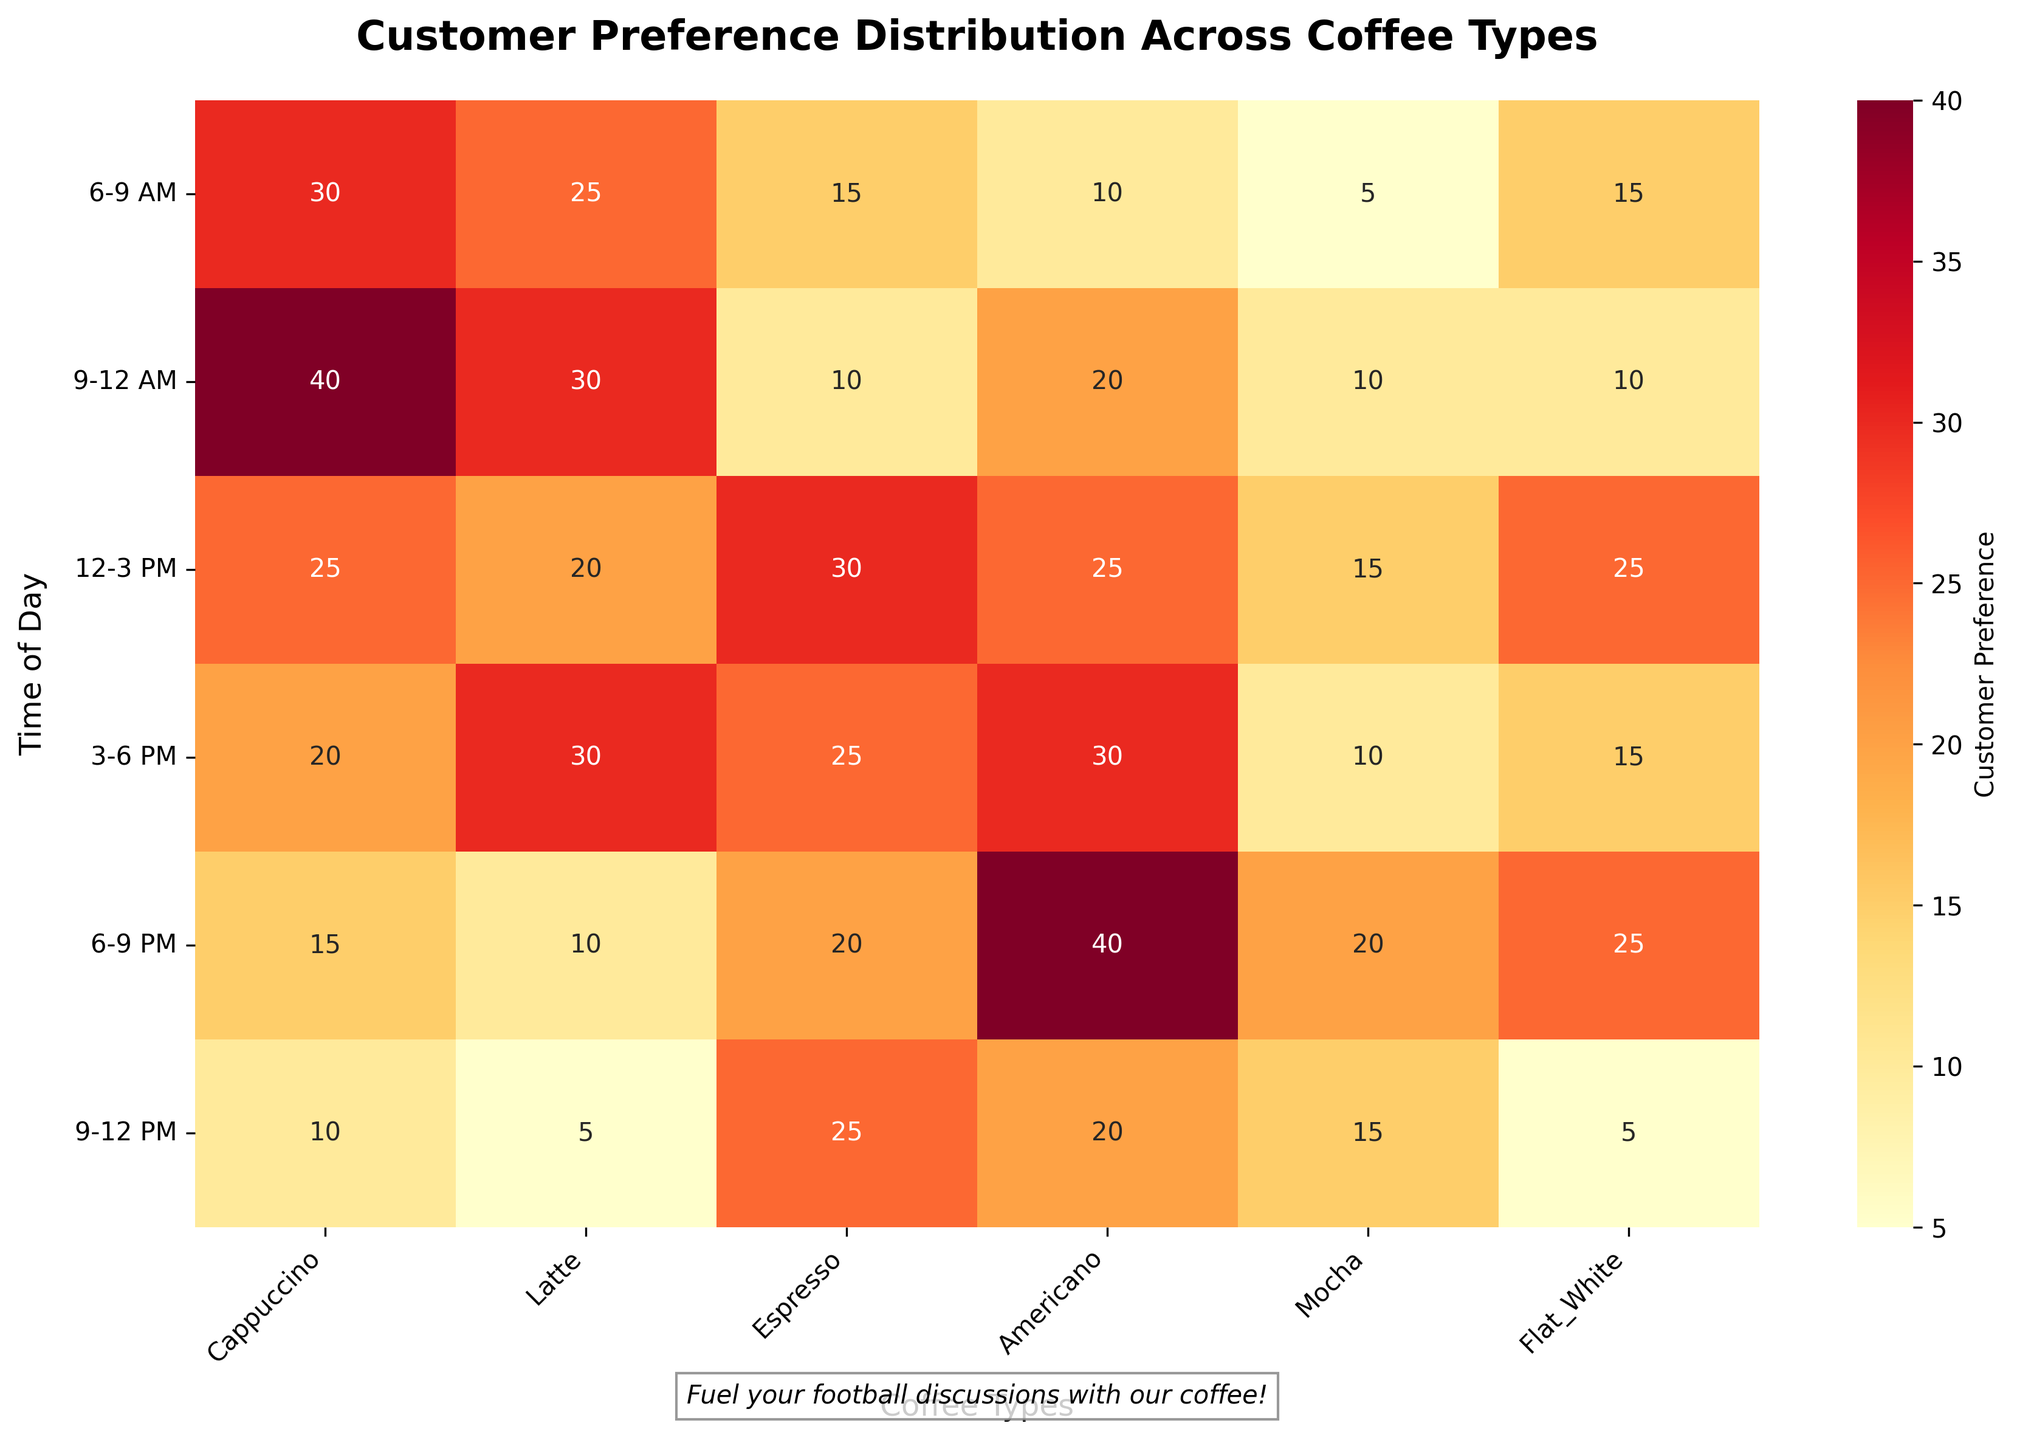What time of day sees the highest customer preference for Cappuccino? The heatmap shows the highest value for Cappuccino in the 9-12 AM slot with a preference count of 40.
Answer: 9-12 AM Which coffee type has the lowest customer preference in the 6-9 AM slot? Look at the 6-9 AM row and find the lowest number; Mocha has the lowest preference count of 5.
Answer: Mocha What is the total customer preference for Latte from 6-9 AM to 9-12 PM? Sum the values for Latte in the 6-9 AM and 9-12 AM slots: 25 + 30 = 55.
Answer: 55 Between Espresso and Americano, which one has more preference during the 6-9 PM slot? Compare the values for Espresso and Americano in the 6-9 PM slot; Espresso has a value of 20 and Americano has a value of 40. Americano has more preference.
Answer: Americano Which time slot has the most uniform distribution of customer preferences across all coffee types? A time slot with similar values across all coffee types is more uniform. The 3-6 PM slot has values that are closer to each other: 20, 30, 25, 30, 10, 15.
Answer: 3-6 PM What is the average preference for Flat White during the 12-3 PM and 6-9 PM slots? Calculate the average by adding the values and dividing by 2: (25 + 25) / 2 = 25.
Answer: 25 How does the preference for Mocha change from 6-9 PM to 9-12 PM? Compare the values: Mocha has 20 for 6-9 PM and 15 for 9-12 PM, indicating a decrease by 5.
Answer: Decreases by 5 In which time slot does Americano see its peak preference? Find the highest value in the Americano column: 40 during the 6-9 PM slot.
Answer: 6-9 PM Is there any time slot where Espresso is the most preferred coffee type? Look through each row to see if the highest number belongs to Espresso within any slot. It is highest in the 12-3 PM slot with a preference of 30.
Answer: 12-3 PM 